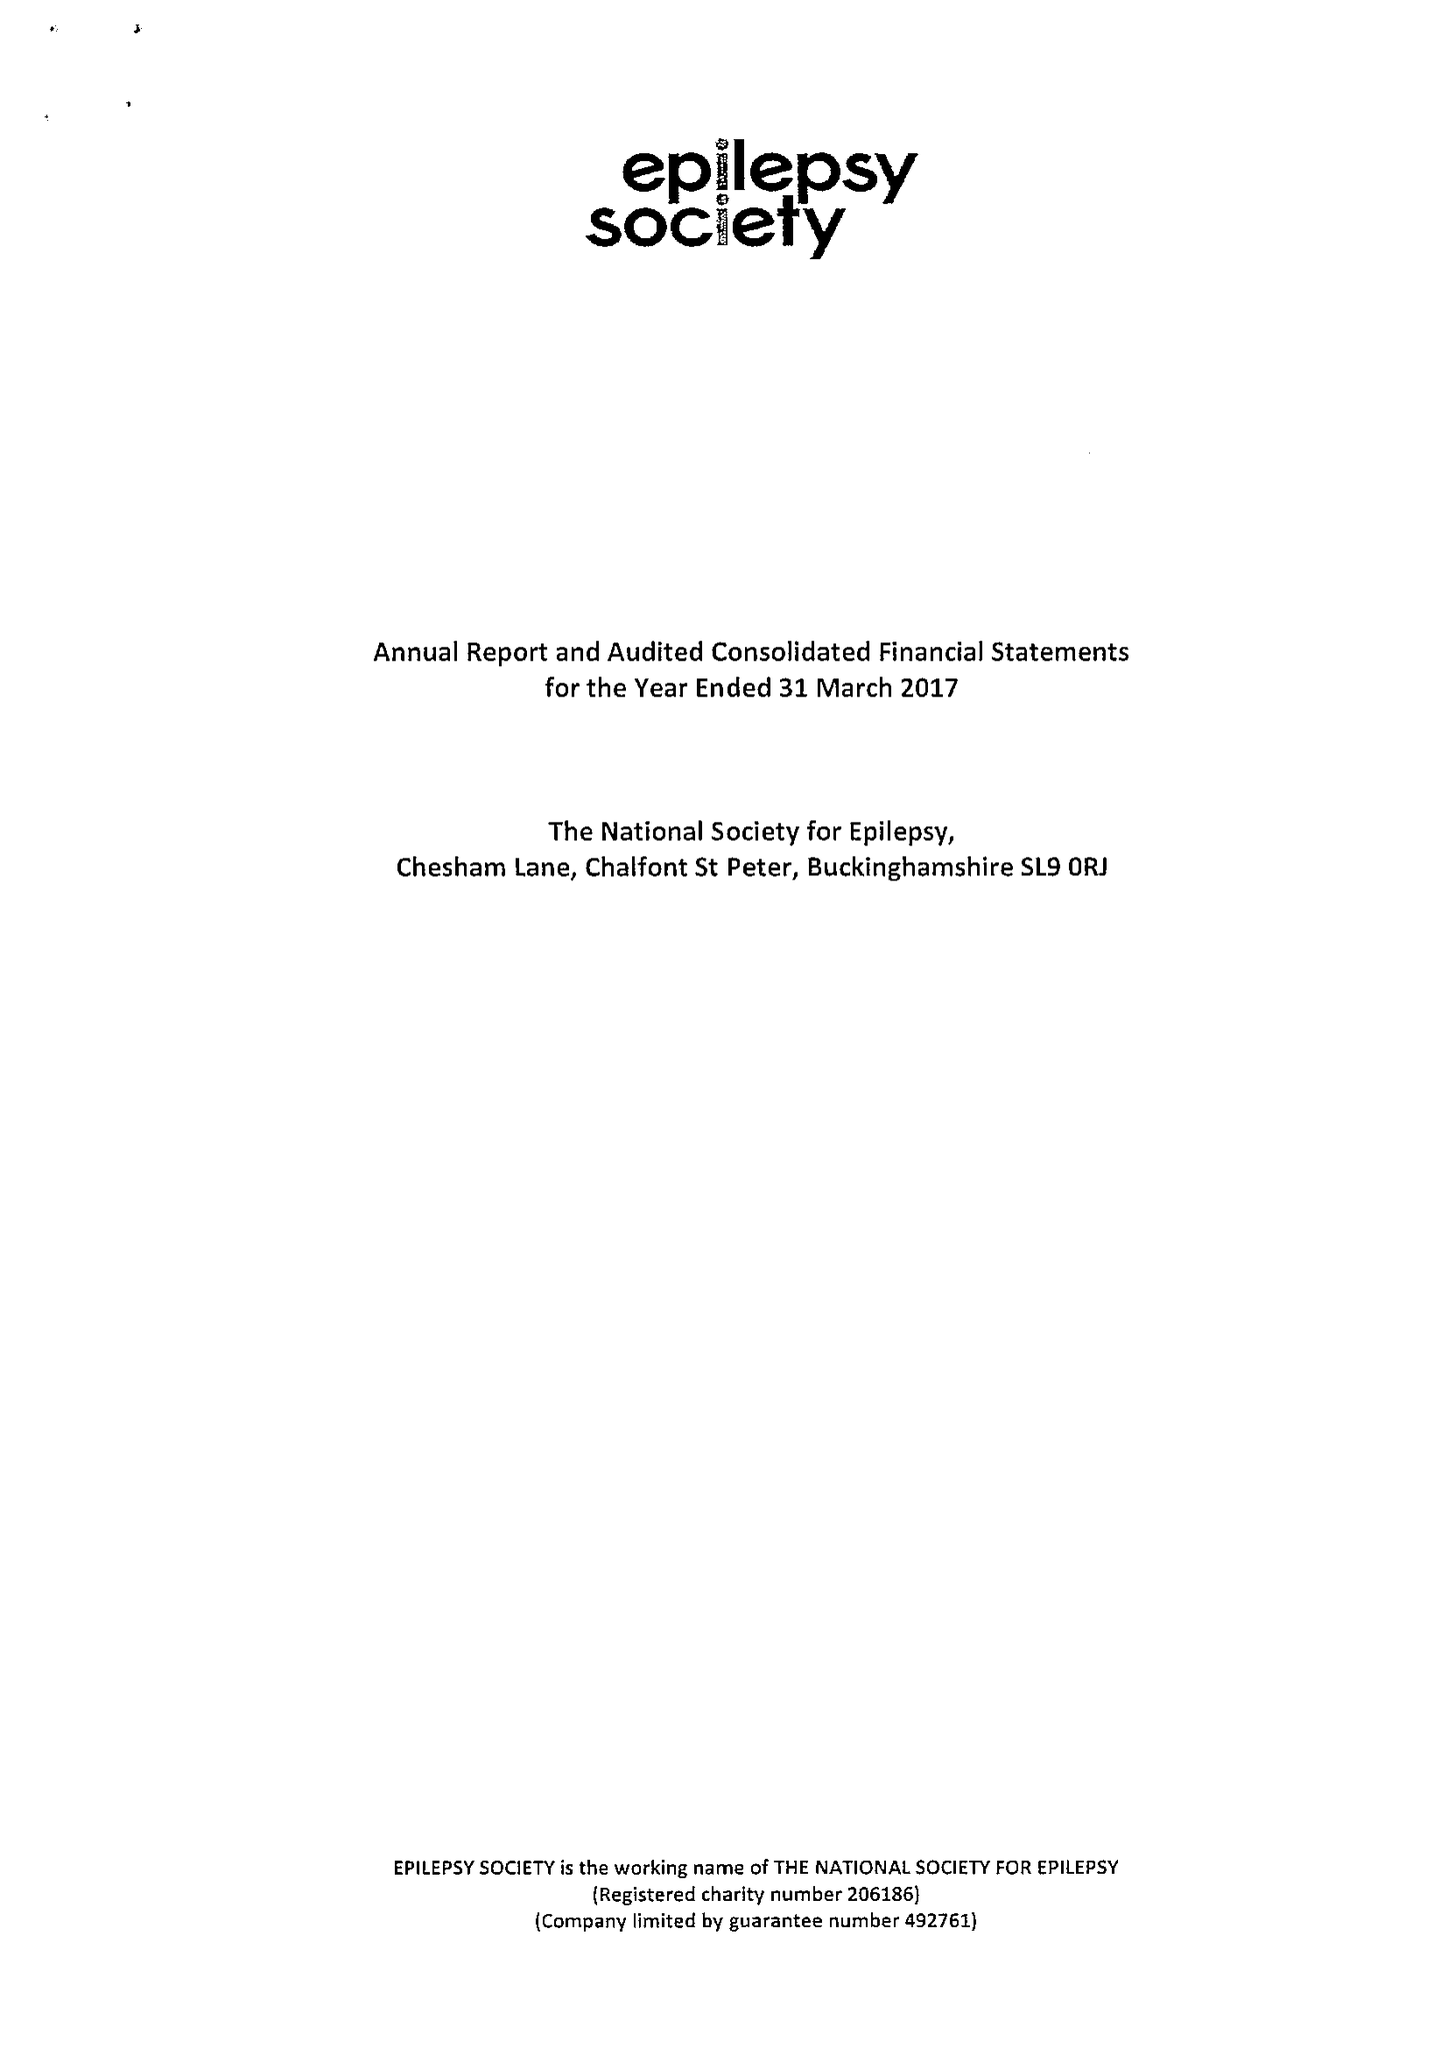What is the value for the income_annually_in_british_pounds?
Answer the question using a single word or phrase. 17056000.00 